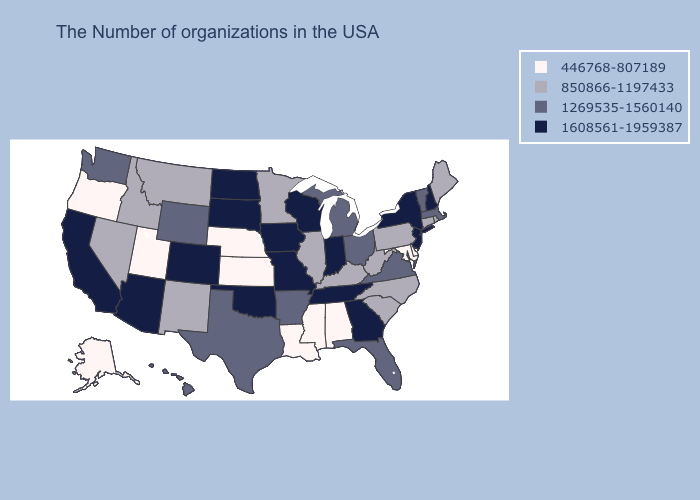Which states have the lowest value in the South?
Be succinct. Delaware, Maryland, Alabama, Mississippi, Louisiana. Which states have the lowest value in the USA?
Answer briefly. Delaware, Maryland, Alabama, Mississippi, Louisiana, Kansas, Nebraska, Utah, Oregon, Alaska. Name the states that have a value in the range 1269535-1560140?
Quick response, please. Massachusetts, Vermont, Virginia, Ohio, Florida, Michigan, Arkansas, Texas, Wyoming, Washington, Hawaii. Does Oklahoma have a higher value than Oregon?
Be succinct. Yes. Name the states that have a value in the range 446768-807189?
Give a very brief answer. Delaware, Maryland, Alabama, Mississippi, Louisiana, Kansas, Nebraska, Utah, Oregon, Alaska. Does the map have missing data?
Short answer required. No. Which states hav the highest value in the MidWest?
Be succinct. Indiana, Wisconsin, Missouri, Iowa, South Dakota, North Dakota. Among the states that border Kentucky , does Missouri have the lowest value?
Keep it brief. No. Does Tennessee have the highest value in the South?
Short answer required. Yes. What is the highest value in the USA?
Write a very short answer. 1608561-1959387. Does Alaska have the lowest value in the USA?
Write a very short answer. Yes. Which states have the highest value in the USA?
Give a very brief answer. New Hampshire, New York, New Jersey, Georgia, Indiana, Tennessee, Wisconsin, Missouri, Iowa, Oklahoma, South Dakota, North Dakota, Colorado, Arizona, California. Name the states that have a value in the range 446768-807189?
Answer briefly. Delaware, Maryland, Alabama, Mississippi, Louisiana, Kansas, Nebraska, Utah, Oregon, Alaska. What is the lowest value in the USA?
Quick response, please. 446768-807189. Which states have the lowest value in the MidWest?
Concise answer only. Kansas, Nebraska. 